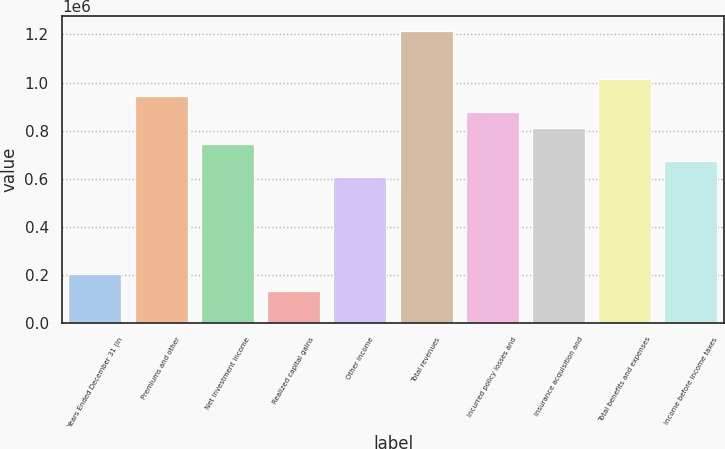Convert chart. <chart><loc_0><loc_0><loc_500><loc_500><bar_chart><fcel>Years Ended December 31 (in<fcel>Premiums and other<fcel>Net investment income<fcel>Realized capital gains<fcel>Other income<fcel>Total revenues<fcel>Incurred policy losses and<fcel>Insurance acquisition and<fcel>Total benefits and expenses<fcel>Income before income taxes<nl><fcel>202681<fcel>945843<fcel>743162<fcel>135121<fcel>608042<fcel>1.21608e+06<fcel>878283<fcel>810722<fcel>1.0134e+06<fcel>675602<nl></chart> 